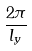Convert formula to latex. <formula><loc_0><loc_0><loc_500><loc_500>\frac { 2 \pi } { l _ { y } }</formula> 